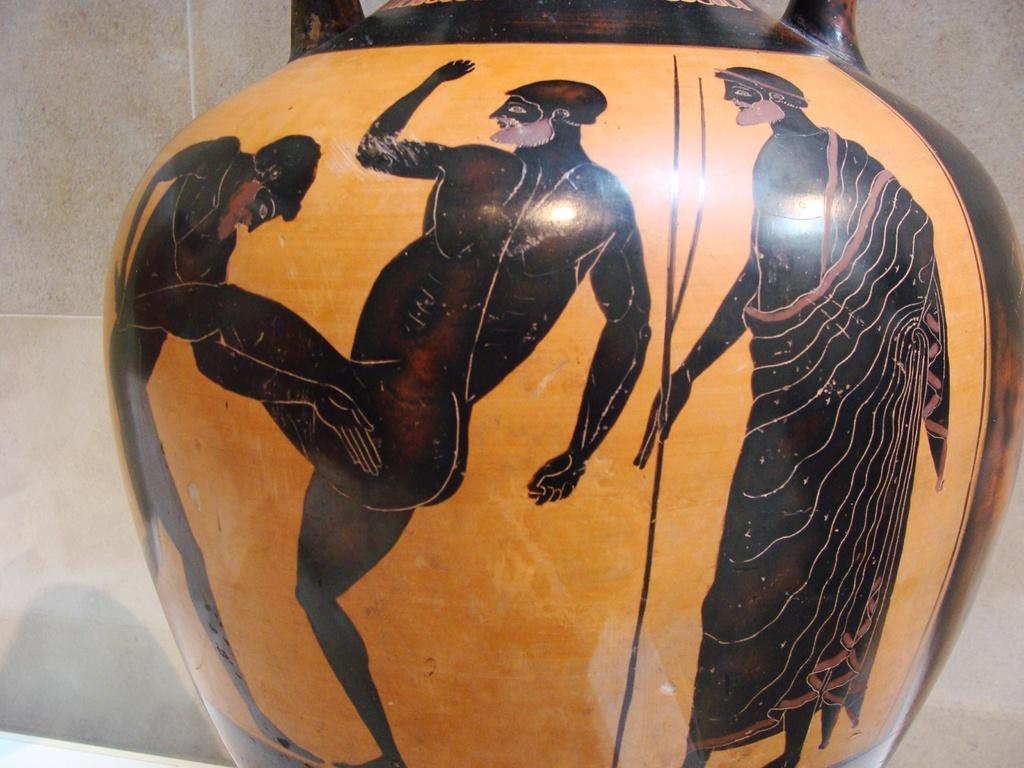What is the main subject in the center of the image? There is a pot in the center of the image. What colors are used for the pot? The pot is in black and yellow color. What can be seen on the pot? There are three human images on the pot. What is visible in the background of the image? There is a wall in the background of the image. How many ranges are visible in the image? There are no ranges present in the image. What type of van can be seen parked near the pot in the image? There is no van present in the image. 